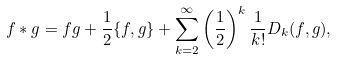<formula> <loc_0><loc_0><loc_500><loc_500>f * g = f g + \frac { 1 } { 2 } \{ f , g \} + \sum _ { k = 2 } ^ { \infty } \left ( \frac { 1 } { 2 } \right ) ^ { k } \frac { 1 } { k ! } D _ { k } ( f , g ) ,</formula> 